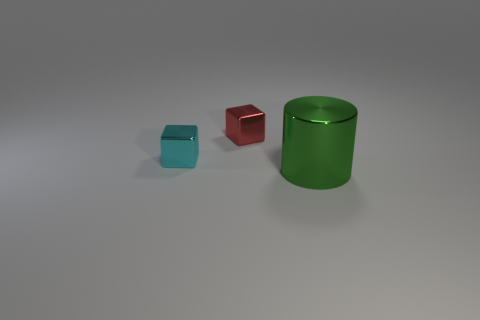Is the number of tiny cyan shiny things that are left of the green metal cylinder greater than the number of tiny blue cubes?
Offer a terse response. Yes. How many other things are the same color as the big object?
Your answer should be very brief. 0. Is the number of small cubes greater than the number of large green rubber objects?
Give a very brief answer. Yes. Is the size of the cube right of the cyan metallic object the same as the small cyan thing?
Give a very brief answer. Yes. There is a thing right of the red metallic block; how big is it?
Offer a terse response. Large. What number of large green cylinders are there?
Provide a short and direct response. 1. There is a thing that is both to the right of the cyan metallic block and in front of the red cube; what is its color?
Provide a succinct answer. Green. There is a tiny cyan cube; are there any tiny red things right of it?
Provide a short and direct response. Yes. What number of large green metal things are on the left side of the object behind the cyan metallic object?
Give a very brief answer. 0. What size is the red object that is made of the same material as the small cyan block?
Your answer should be very brief. Small. 